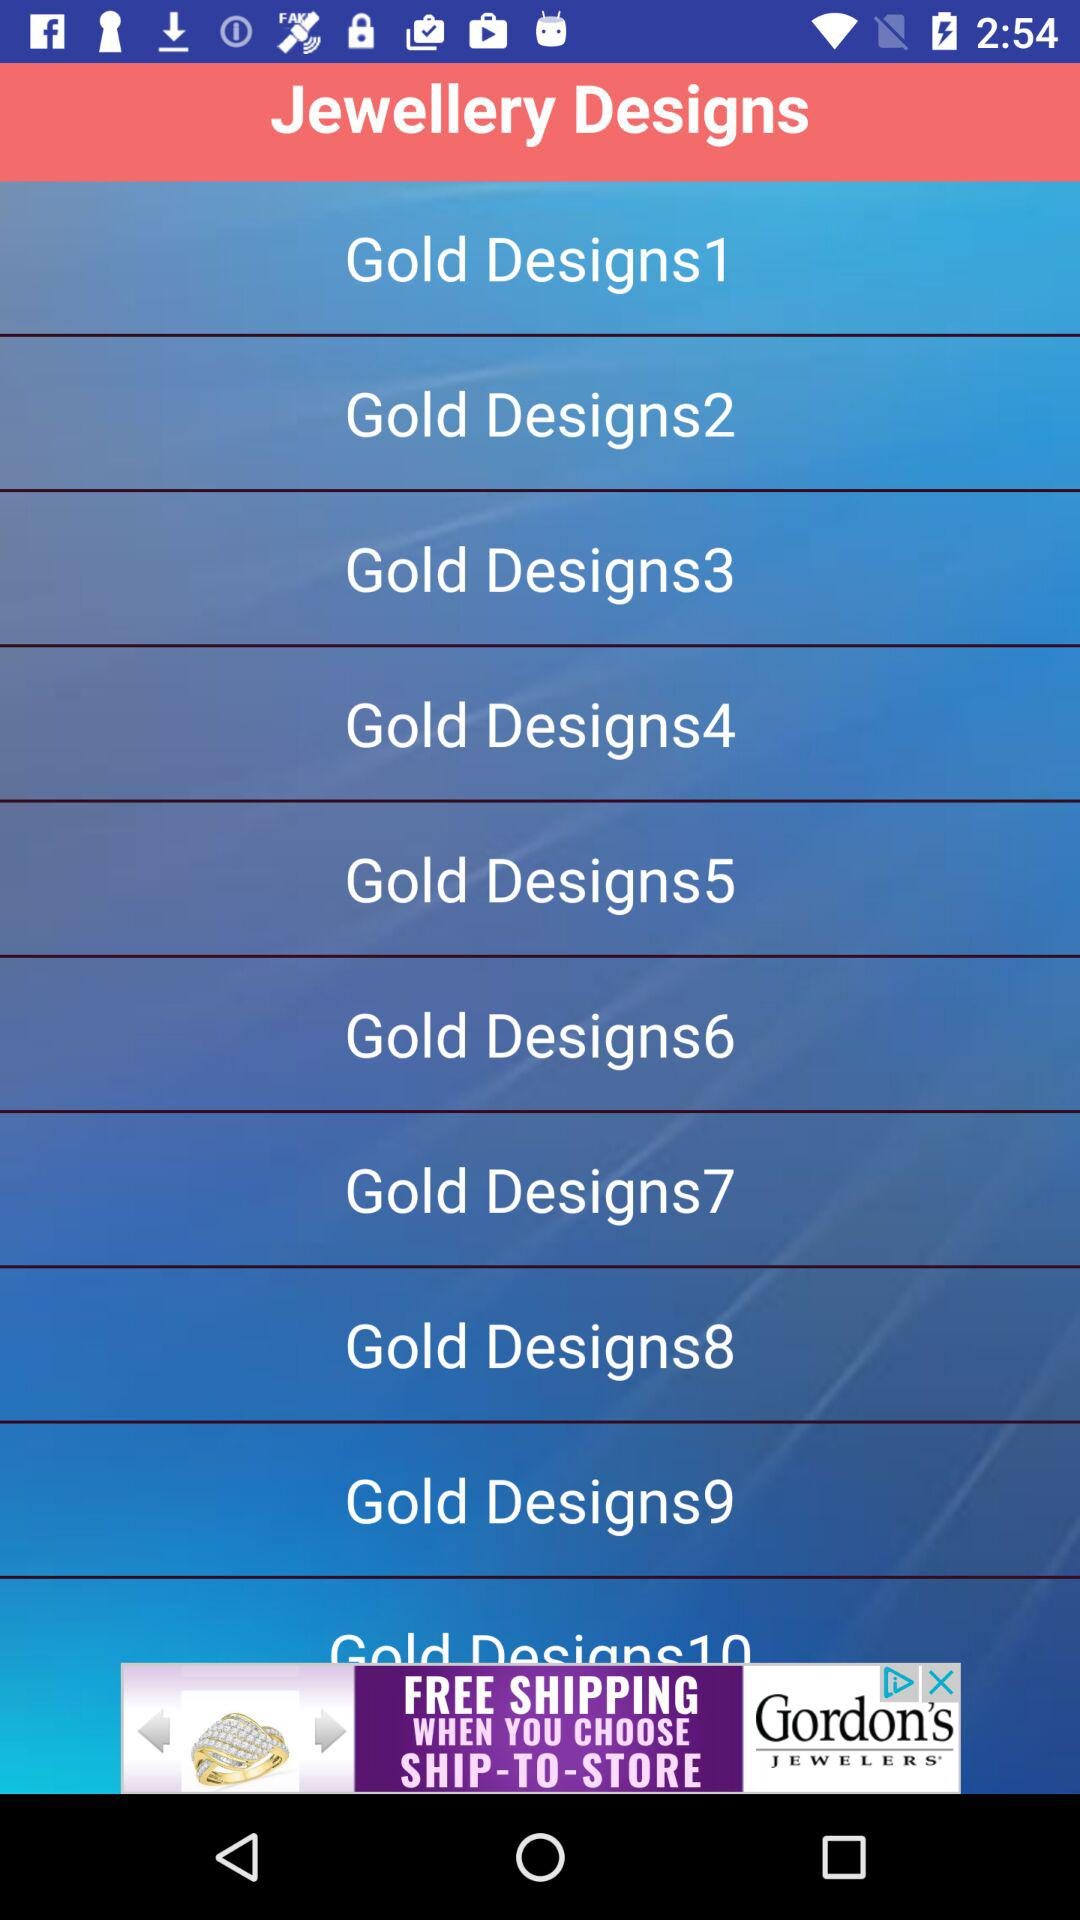How many gold designs are there?
Answer the question using a single word or phrase. 10 